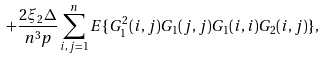Convert formula to latex. <formula><loc_0><loc_0><loc_500><loc_500>+ \frac { 2 \xi _ { 2 } \Delta } { n ^ { 3 } p } \sum _ { i , j = 1 } ^ { n } { E } \{ G _ { 1 } ^ { 2 } ( i , j ) G _ { 1 } ( j , j ) G _ { 1 } ( i , i ) G _ { 2 } ( i , j ) \} ,</formula> 